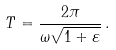Convert formula to latex. <formula><loc_0><loc_0><loc_500><loc_500>T = \frac { 2 \pi } { \omega \sqrt { 1 + \varepsilon } } \, .</formula> 